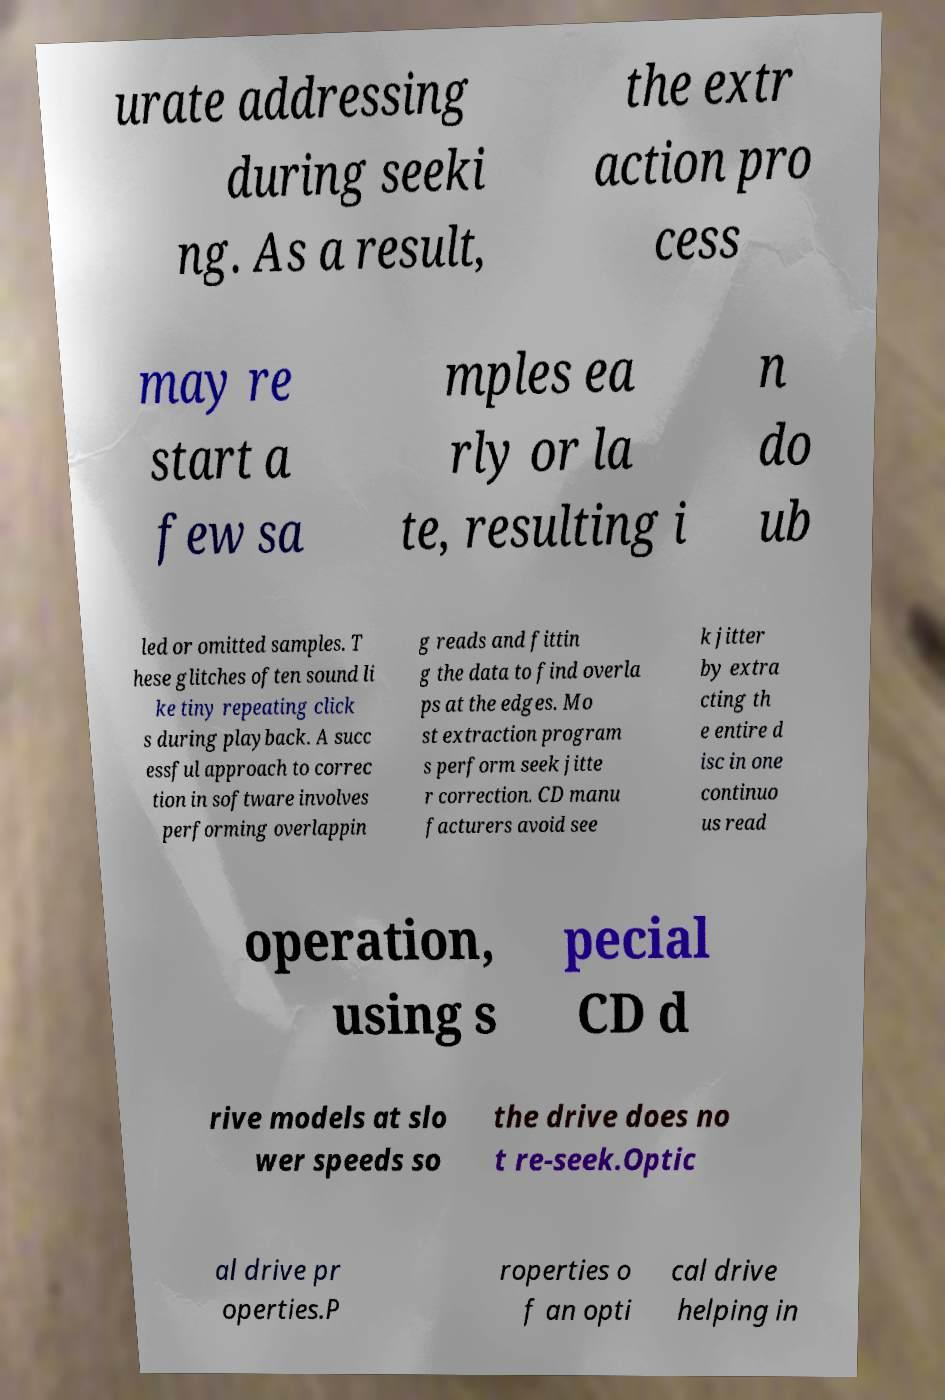Could you extract and type out the text from this image? urate addressing during seeki ng. As a result, the extr action pro cess may re start a few sa mples ea rly or la te, resulting i n do ub led or omitted samples. T hese glitches often sound li ke tiny repeating click s during playback. A succ essful approach to correc tion in software involves performing overlappin g reads and fittin g the data to find overla ps at the edges. Mo st extraction program s perform seek jitte r correction. CD manu facturers avoid see k jitter by extra cting th e entire d isc in one continuo us read operation, using s pecial CD d rive models at slo wer speeds so the drive does no t re-seek.Optic al drive pr operties.P roperties o f an opti cal drive helping in 